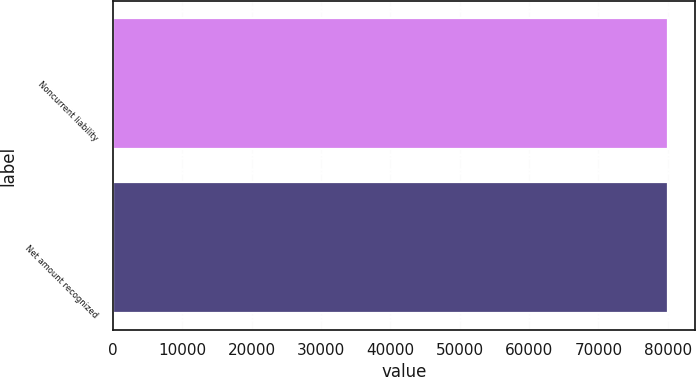Convert chart to OTSL. <chart><loc_0><loc_0><loc_500><loc_500><bar_chart><fcel>Noncurrent liability<fcel>Net amount recognized<nl><fcel>79969<fcel>79969.1<nl></chart> 